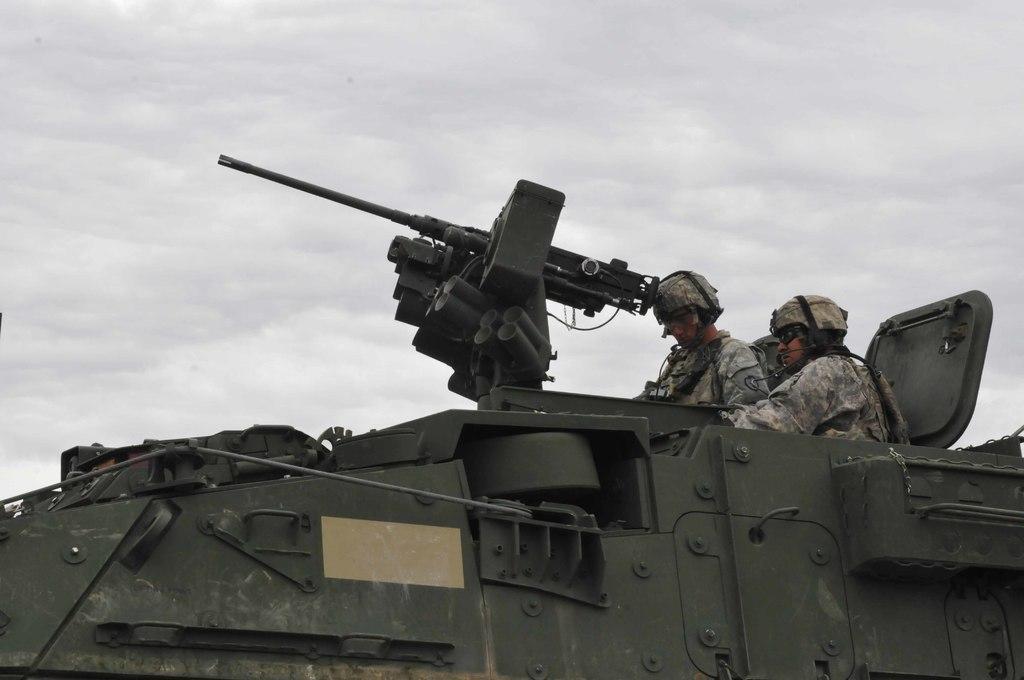Please provide a concise description of this image. In the image there is a war tanker. Inside the tanker there are two men with helmets and goggles. In the background there is sky. 